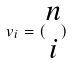Convert formula to latex. <formula><loc_0><loc_0><loc_500><loc_500>v _ { i } = ( \begin{matrix} n \\ i \end{matrix} )</formula> 